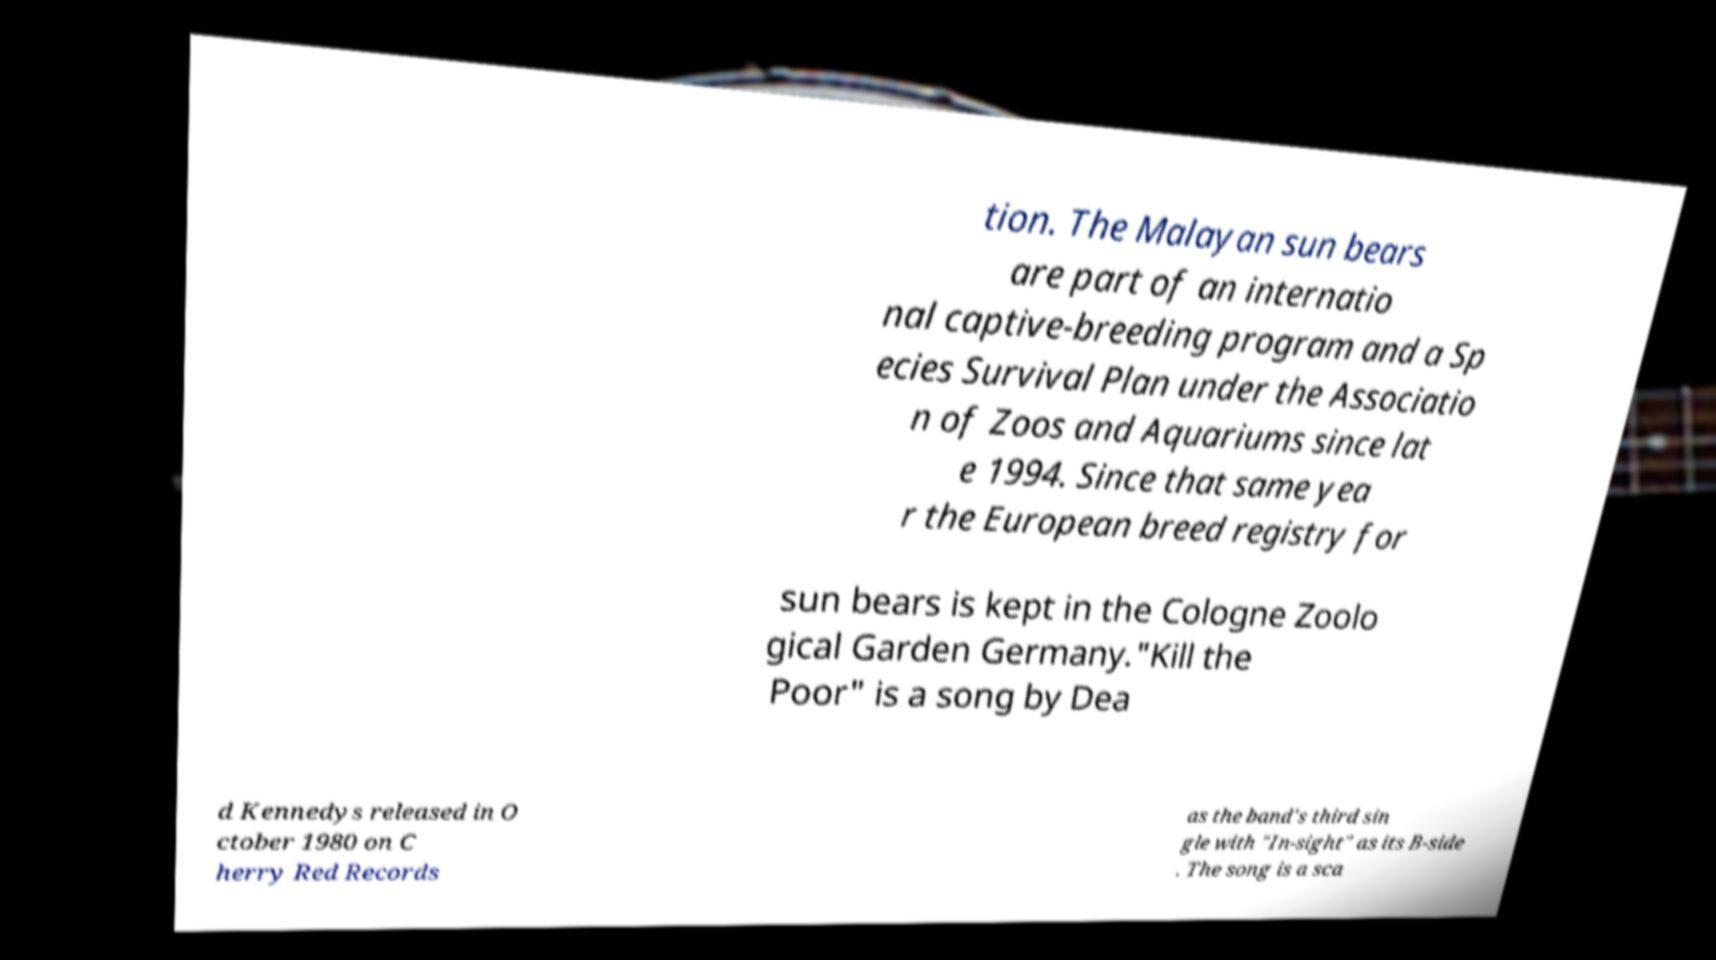Can you read and provide the text displayed in the image?This photo seems to have some interesting text. Can you extract and type it out for me? tion. The Malayan sun bears are part of an internatio nal captive-breeding program and a Sp ecies Survival Plan under the Associatio n of Zoos and Aquariums since lat e 1994. Since that same yea r the European breed registry for sun bears is kept in the Cologne Zoolo gical Garden Germany."Kill the Poor" is a song by Dea d Kennedys released in O ctober 1980 on C herry Red Records as the band's third sin gle with "In-sight" as its B-side . The song is a sca 